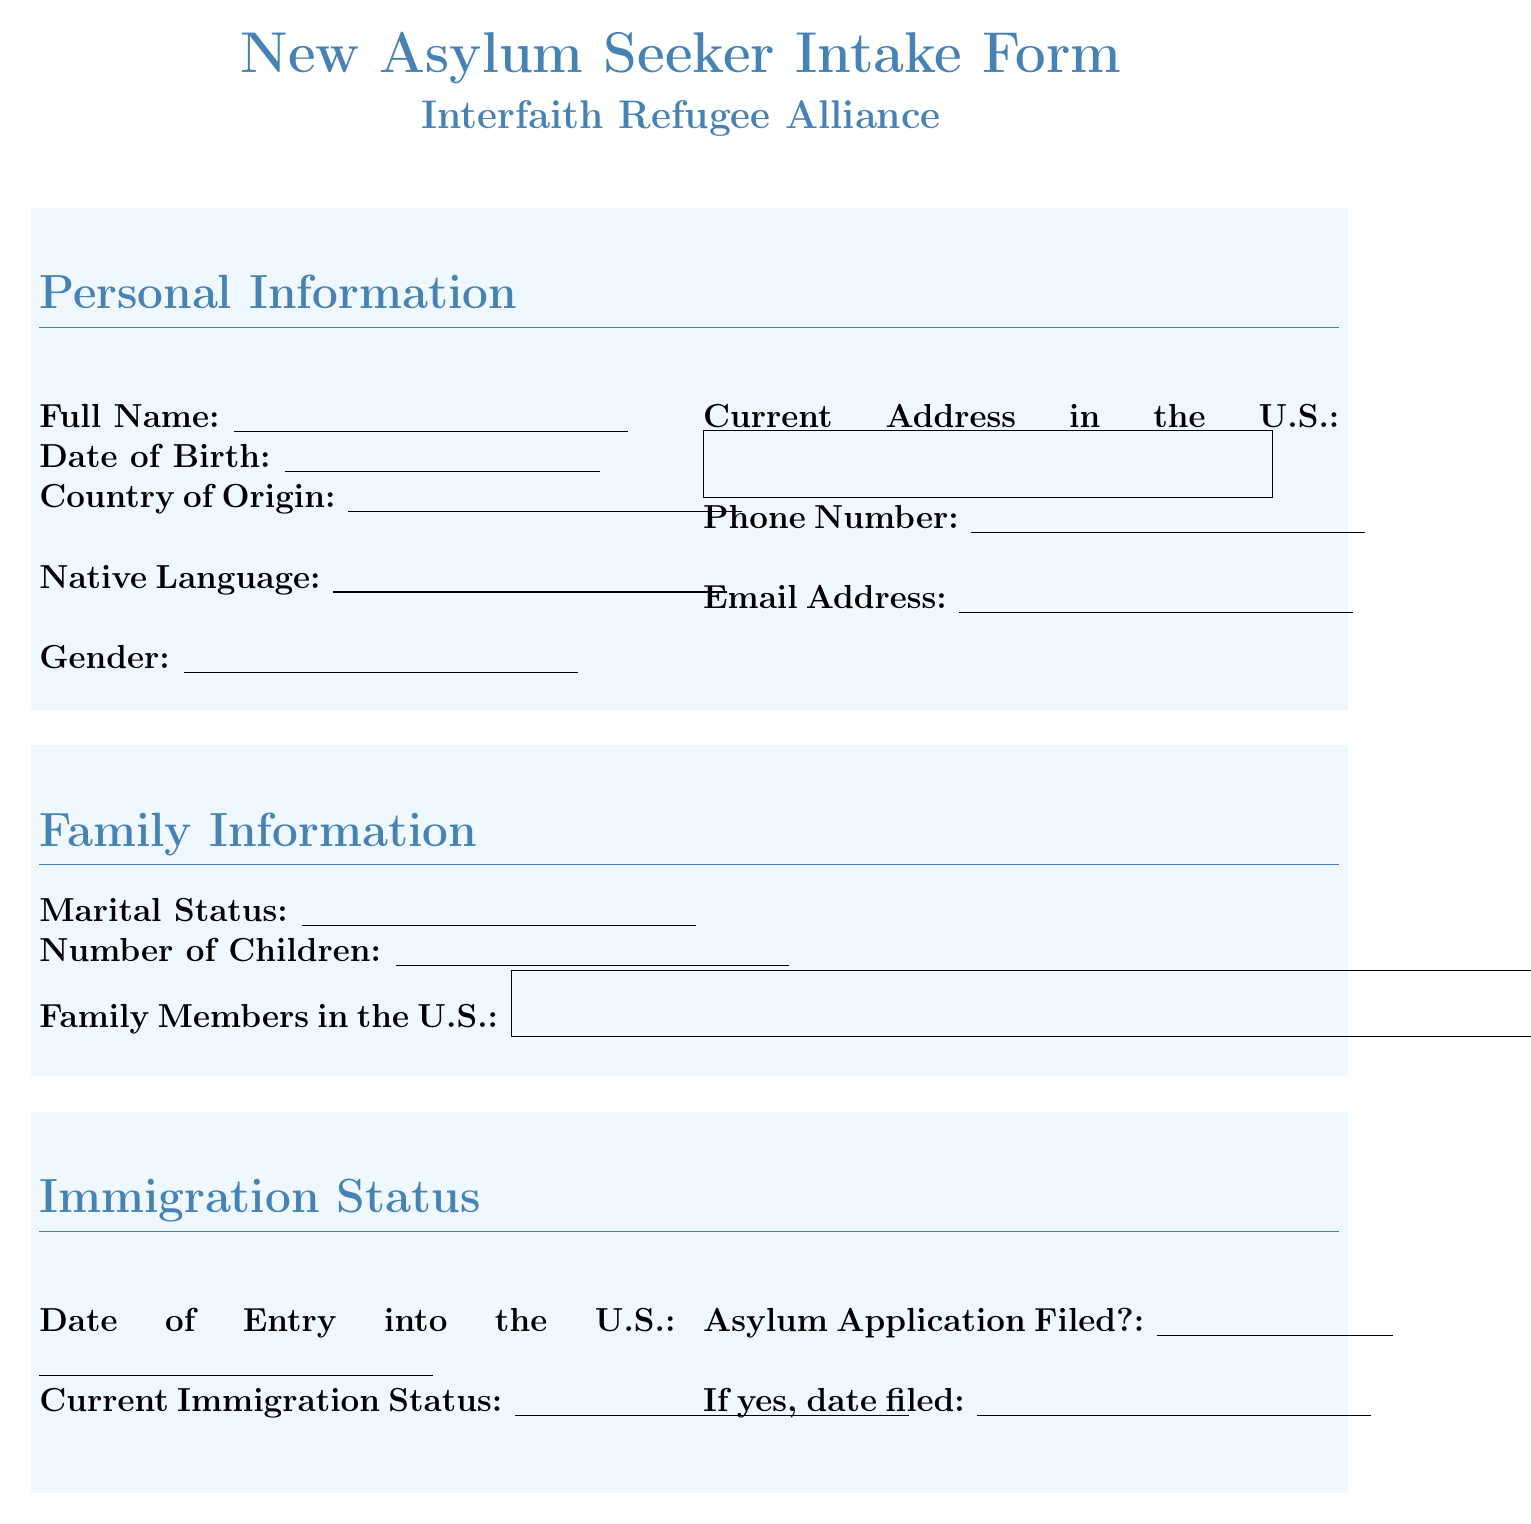What is the title of the form? The title of the form is prominently displayed at the top of the document.
Answer: New Asylum Seeker Intake Form What is the name of the organization? The name of the organization is stated right under the title of the form.
Answer: Interfaith Refugee Alliance What is the required field for date of birth? The document specifies that the field for date of birth must be filled out.
Answer: Date of Birth How many options are provided for gender? The document lists the selectable options for gender which indicates the number.
Answer: Four What is one option for the reason for seeking asylum? The document provides several options under the asylum claim section.
Answer: Political Opinion How many sections are there in the form? By counting the numbered sections, we can determine the total.
Answer: Six Is an email address a required field? The document clearly notes which fields are necessary and which are not.
Answer: No What type of assistance is mentioned under support needs? The document includes several forms of assistance necessary for asylum seekers.
Answer: Housing Assistance Needed What consent is required from the applicant? The document specifies a particular consent that must be acknowledged for data use.
Answer: I consent to Interfaith Refugee Alliance storing and using my information to assist with my case 